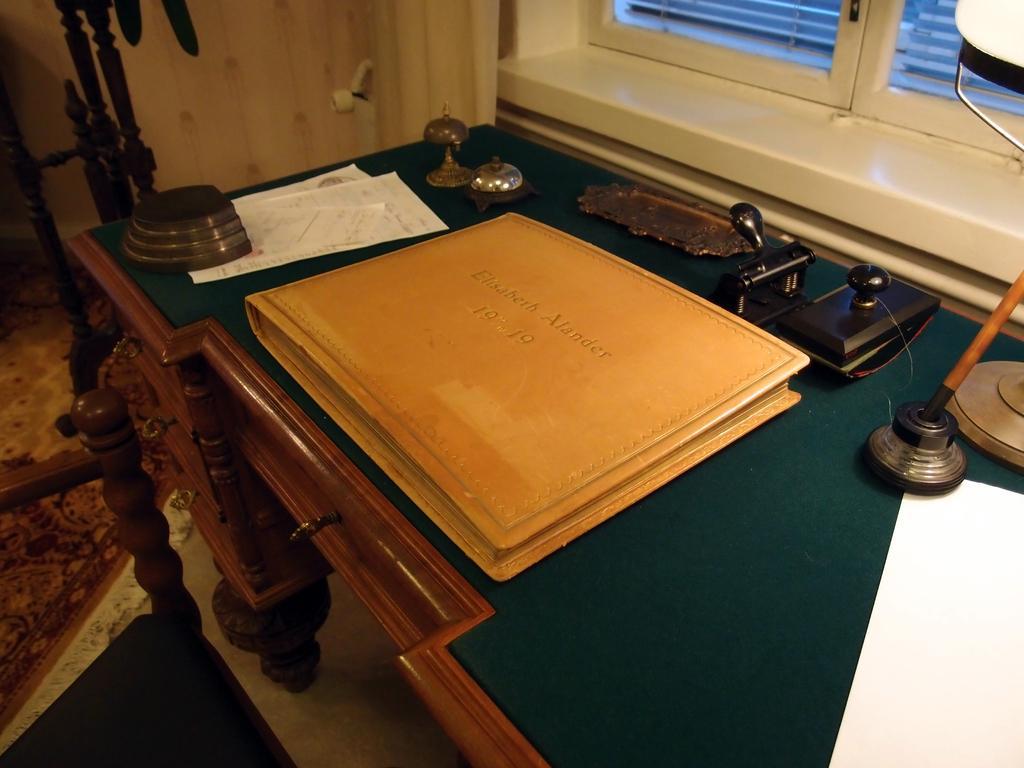Could you give a brief overview of what you see in this image? In this picture is a table with the file connect and in the background there is a window 